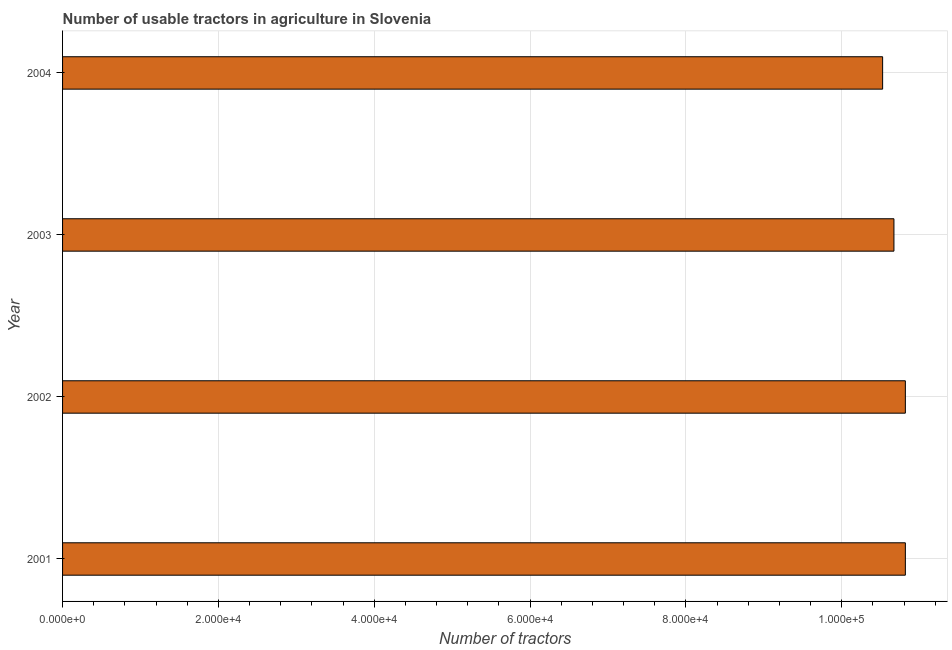What is the title of the graph?
Offer a very short reply. Number of usable tractors in agriculture in Slovenia. What is the label or title of the X-axis?
Give a very brief answer. Number of tractors. What is the number of tractors in 2002?
Provide a short and direct response. 1.08e+05. Across all years, what is the maximum number of tractors?
Your answer should be very brief. 1.08e+05. Across all years, what is the minimum number of tractors?
Your response must be concise. 1.05e+05. In which year was the number of tractors minimum?
Offer a terse response. 2004. What is the sum of the number of tractors?
Your response must be concise. 4.28e+05. What is the difference between the number of tractors in 2001 and 2004?
Your answer should be very brief. 2916. What is the average number of tractors per year?
Ensure brevity in your answer.  1.07e+05. What is the median number of tractors?
Offer a terse response. 1.07e+05. What is the ratio of the number of tractors in 2002 to that in 2003?
Keep it short and to the point. 1.01. What is the difference between the highest and the lowest number of tractors?
Your answer should be compact. 2916. In how many years, is the number of tractors greater than the average number of tractors taken over all years?
Your answer should be compact. 2. How many bars are there?
Give a very brief answer. 4. Are the values on the major ticks of X-axis written in scientific E-notation?
Your response must be concise. Yes. What is the Number of tractors of 2001?
Keep it short and to the point. 1.08e+05. What is the Number of tractors of 2002?
Keep it short and to the point. 1.08e+05. What is the Number of tractors in 2003?
Offer a terse response. 1.07e+05. What is the Number of tractors in 2004?
Provide a short and direct response. 1.05e+05. What is the difference between the Number of tractors in 2001 and 2002?
Your response must be concise. 0. What is the difference between the Number of tractors in 2001 and 2003?
Provide a short and direct response. 1466. What is the difference between the Number of tractors in 2001 and 2004?
Provide a succinct answer. 2916. What is the difference between the Number of tractors in 2002 and 2003?
Your response must be concise. 1466. What is the difference between the Number of tractors in 2002 and 2004?
Keep it short and to the point. 2916. What is the difference between the Number of tractors in 2003 and 2004?
Keep it short and to the point. 1450. What is the ratio of the Number of tractors in 2001 to that in 2003?
Offer a very short reply. 1.01. What is the ratio of the Number of tractors in 2001 to that in 2004?
Provide a short and direct response. 1.03. What is the ratio of the Number of tractors in 2002 to that in 2003?
Keep it short and to the point. 1.01. What is the ratio of the Number of tractors in 2002 to that in 2004?
Ensure brevity in your answer.  1.03. 